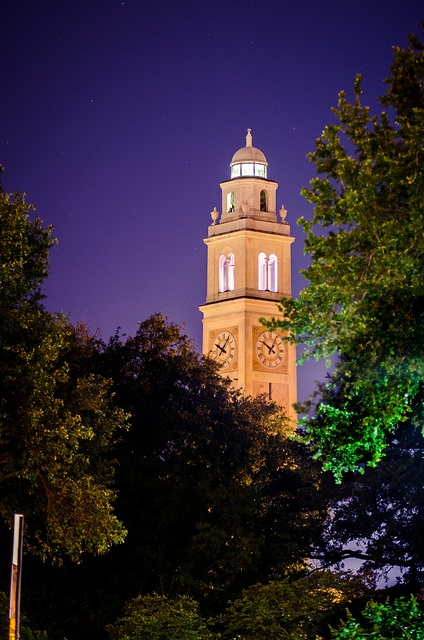Describe the objects in this image and their specific colors. I can see clock in black, tan, brown, red, and salmon tones and clock in black, tan, and brown tones in this image. 